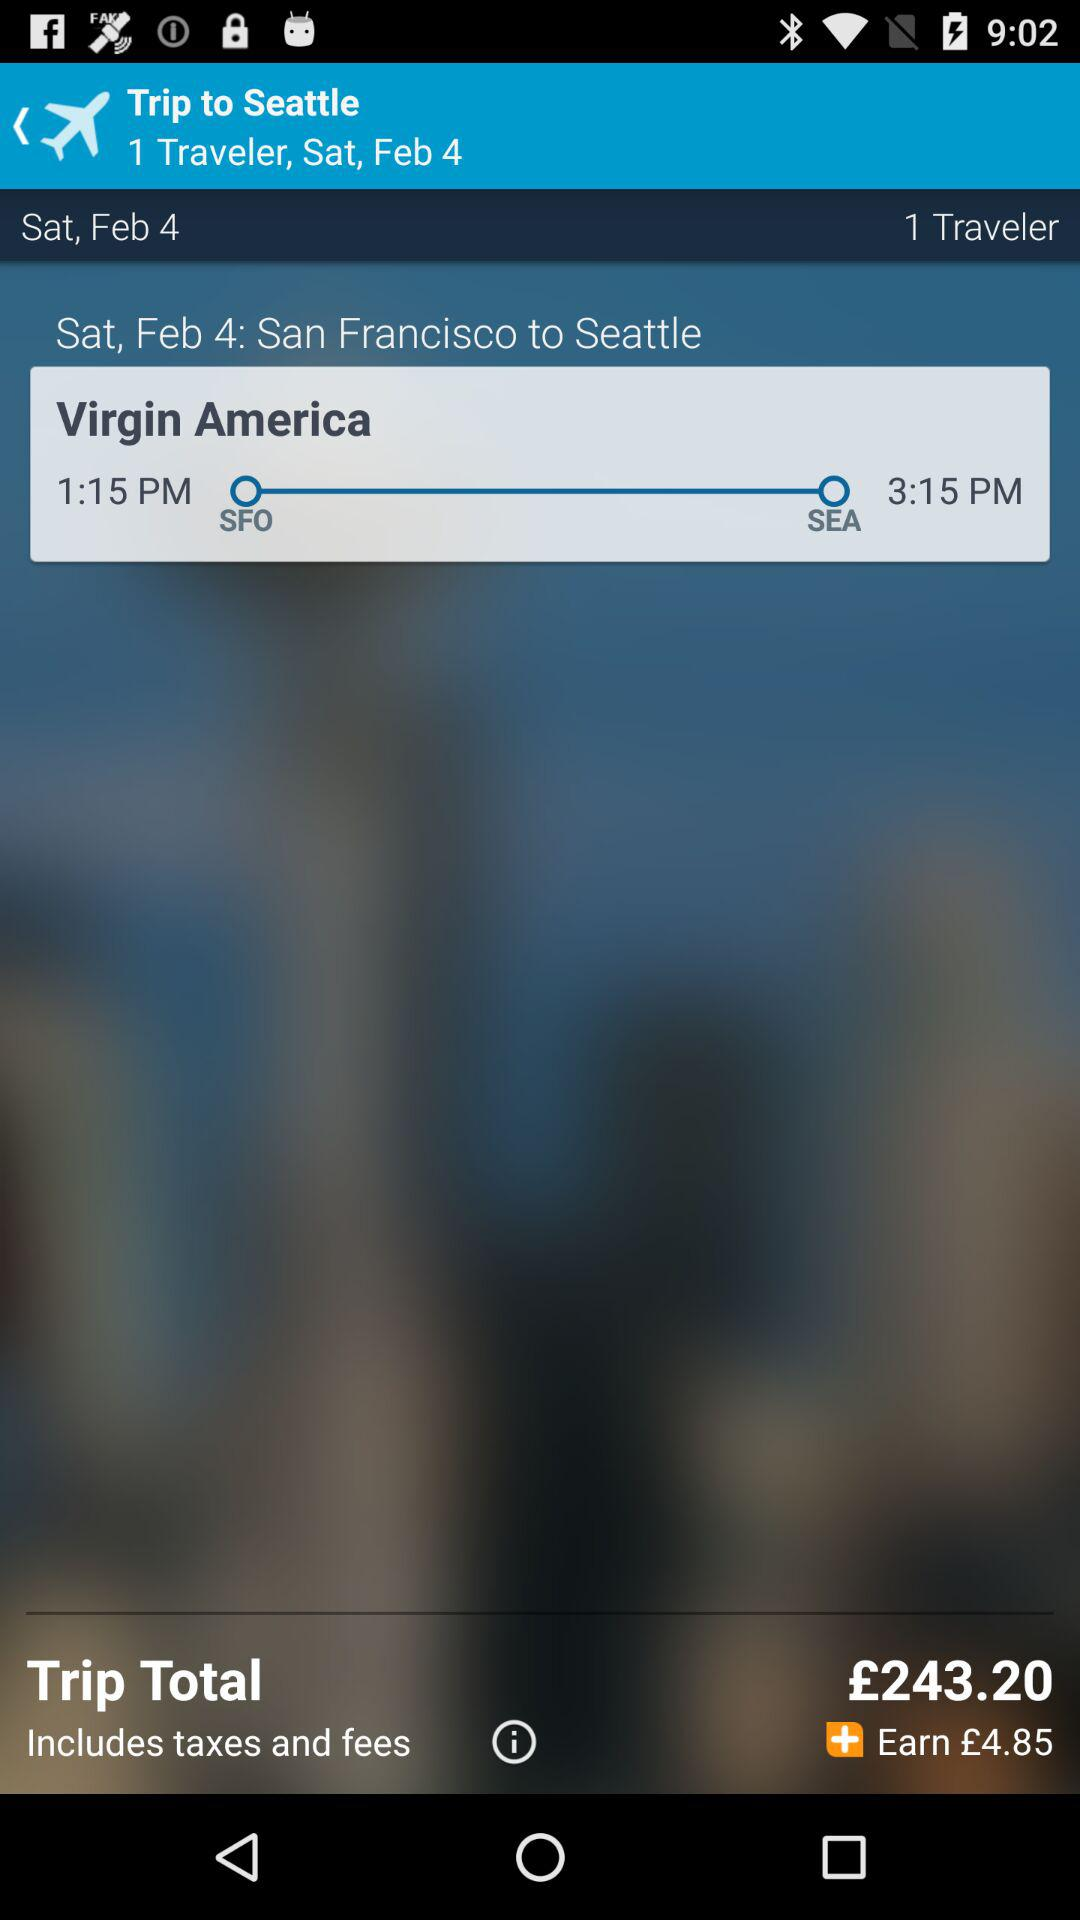How many travelers in total are there? There is one traveler in total. 